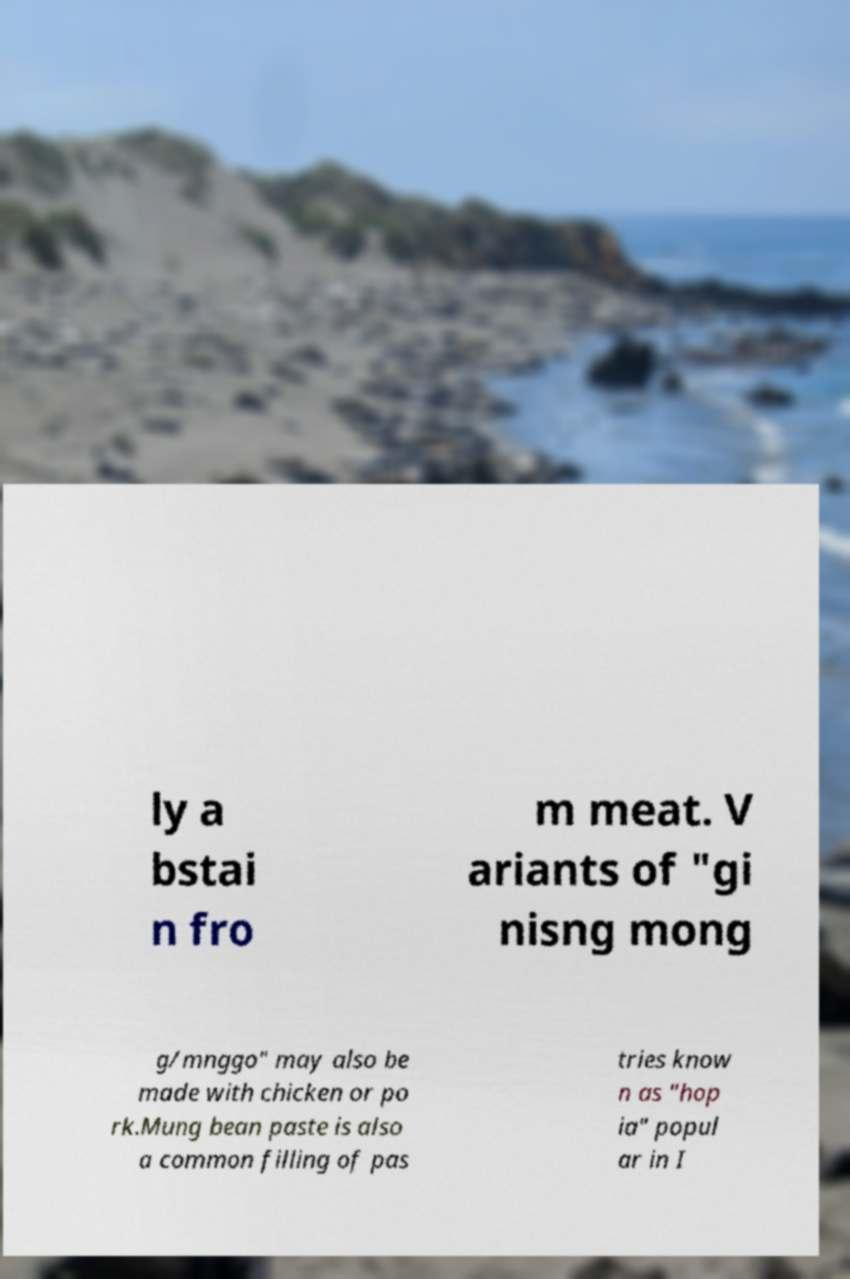Can you accurately transcribe the text from the provided image for me? ly a bstai n fro m meat. V ariants of "gi nisng mong g/mnggo" may also be made with chicken or po rk.Mung bean paste is also a common filling of pas tries know n as "hop ia" popul ar in I 